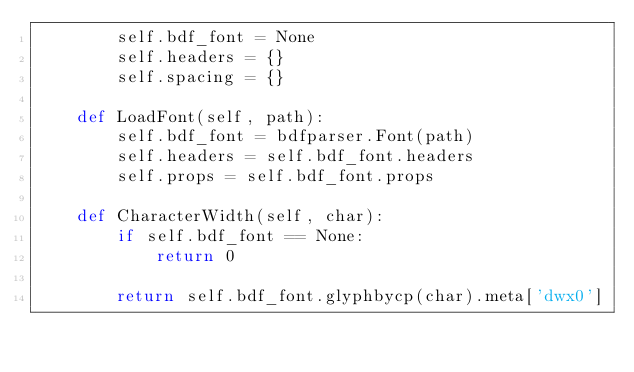Convert code to text. <code><loc_0><loc_0><loc_500><loc_500><_Python_>        self.bdf_font = None
        self.headers = {}
        self.spacing = {}

    def LoadFont(self, path):
        self.bdf_font = bdfparser.Font(path)
        self.headers = self.bdf_font.headers
        self.props = self.bdf_font.props

    def CharacterWidth(self, char):
        if self.bdf_font == None:
            return 0

        return self.bdf_font.glyphbycp(char).meta['dwx0']
</code> 